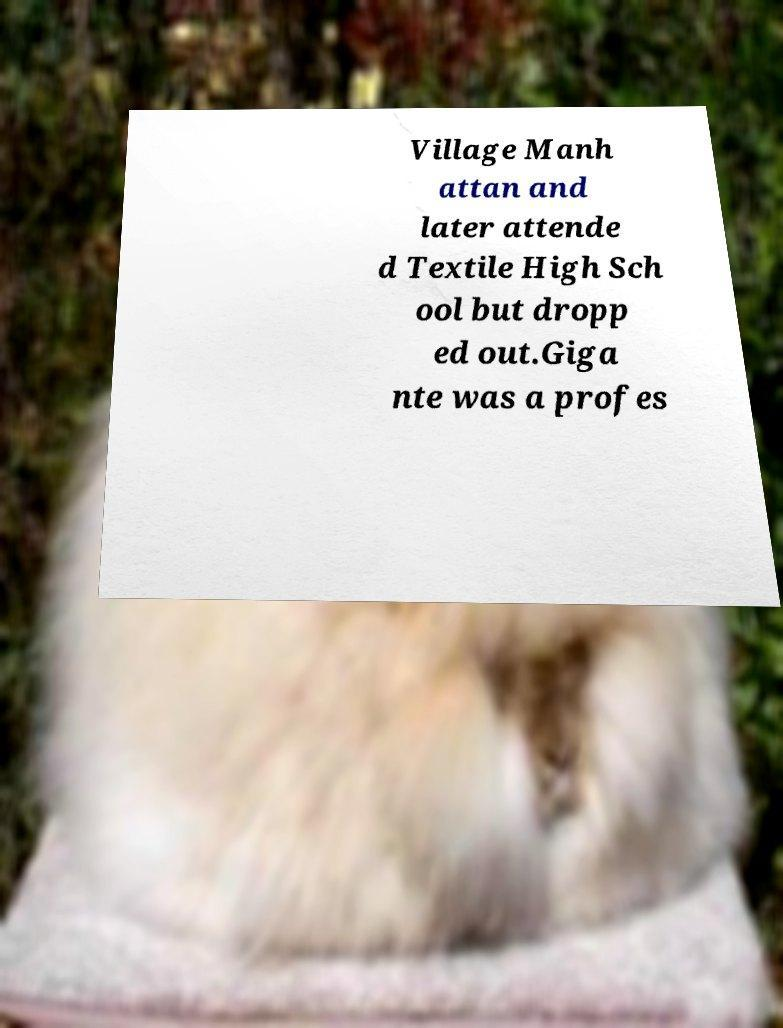Please identify and transcribe the text found in this image. Village Manh attan and later attende d Textile High Sch ool but dropp ed out.Giga nte was a profes 